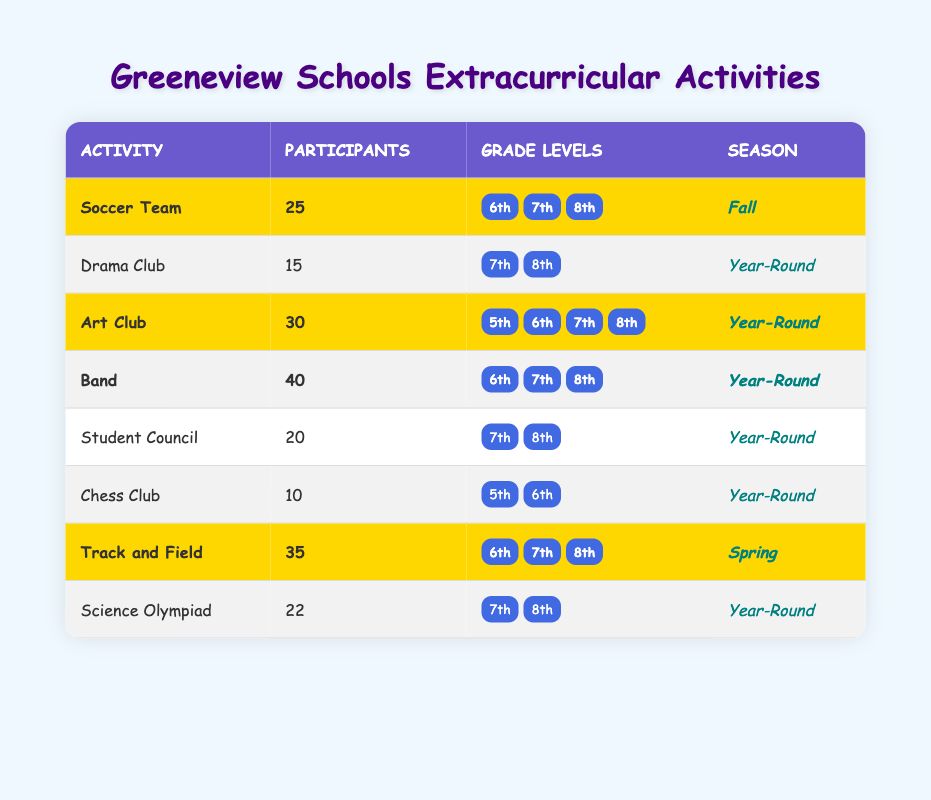How many students participate in the Band activity? The Band activity has a participant count of 40, as listed in the table.
Answer: 40 Which extracurricular activity has the highest number of participants? The table shows that the Band activity has the highest participant count of 40, compared to others.
Answer: Band Is the Drama Club available to 5th graders? The Drama Club is only available to 7th and 8th graders, as indicated in the grade levels section for this activity.
Answer: No How many activities are highlighted in the table? The highlighted activities are Soccer Team, Art Club, Band, and Track and Field, making a total of 4 highlighted activities.
Answer: 4 What is the combined number of participants in the Soccer Team and Track and Field? The Soccer Team has 25 participants and Track and Field has 35 participants. Adding these gives 25 + 35 = 60.
Answer: 60 How many extracurricular activities are available for 6th graders? The table indicates that 6th graders can participate in Soccer Team, Art Club, Band, and Track and Field, totaling 4 activities.
Answer: 4 Is there a Year-Round activity for 5th graders? According to the table, the only activity available for 5th graders is Chess Club, which is also Year-Round, so the answer is yes.
Answer: Yes What percentage of participants from highlighted activities are involved in the Art Club? The total participants in highlighted activities are 40 (Band) + 30 (Art Club) + 25 (Soccer Team) + 35 (Track and Field) = 130. The Art Club has 30 participants. Calculating the percentage gives (30/130)*100 = 23.08%.
Answer: 23.08% How many activities have a participant count greater than 20? The activities with participant counts greater than 20 are Band (40), Art Club (30), Track and Field (35), and Soccer Team (25). This makes 4 activities in total.
Answer: 4 If the average number of participants in each activity is calculated, what is the result? The sum of participants is 25 + 15 + 30 + 40 + 20 + 10 + 35 + 22 = 207. There are 8 activities, so the average is 207 / 8 = 25.875.
Answer: 25.875 